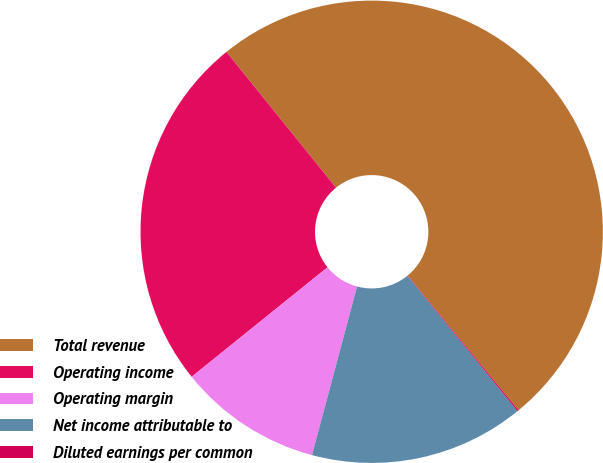Convert chart. <chart><loc_0><loc_0><loc_500><loc_500><pie_chart><fcel>Total revenue<fcel>Operating income<fcel>Operating margin<fcel>Net income attributable to<fcel>Diluted earnings per common<nl><fcel>49.86%<fcel>24.98%<fcel>10.05%<fcel>15.02%<fcel>0.09%<nl></chart> 